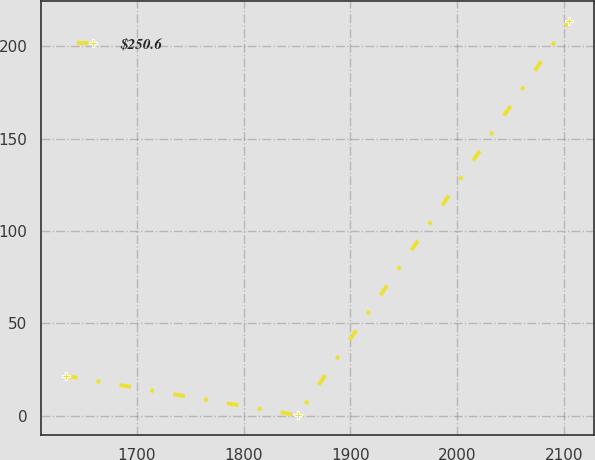Convert chart. <chart><loc_0><loc_0><loc_500><loc_500><line_chart><ecel><fcel>$250.6<nl><fcel>1633.42<fcel>21.56<nl><fcel>1850.74<fcel>0.2<nl><fcel>2105.01<fcel>213.83<nl></chart> 